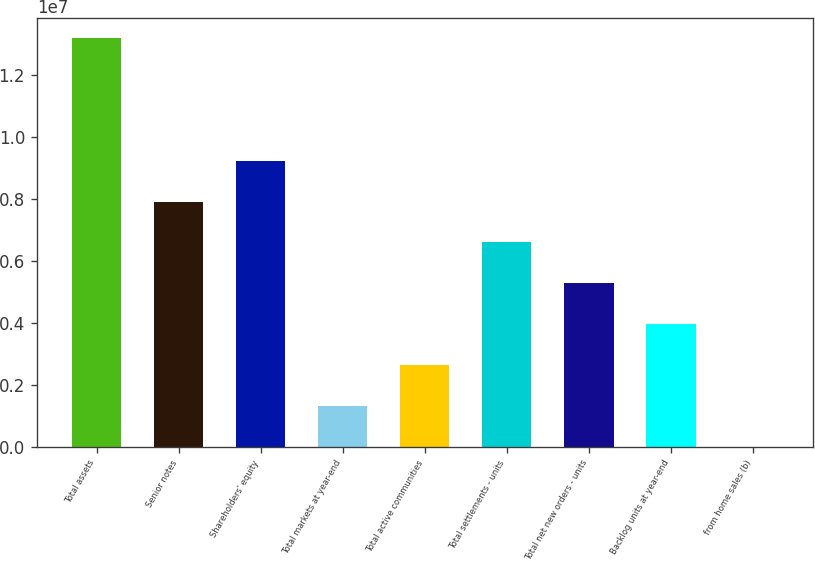Convert chart. <chart><loc_0><loc_0><loc_500><loc_500><bar_chart><fcel>Total assets<fcel>Senior notes<fcel>Shareholders' equity<fcel>Total markets at year-end<fcel>Total active communities<fcel>Total settlements - units<fcel>Total net new orders - units<fcel>Backlog units at year-end<fcel>from home sales (b)<nl><fcel>1.31769e+07<fcel>7.90613e+06<fcel>9.22382e+06<fcel>1.3177e+06<fcel>2.63539e+06<fcel>6.58845e+06<fcel>5.27076e+06<fcel>3.95307e+06<fcel>17.4<nl></chart> 